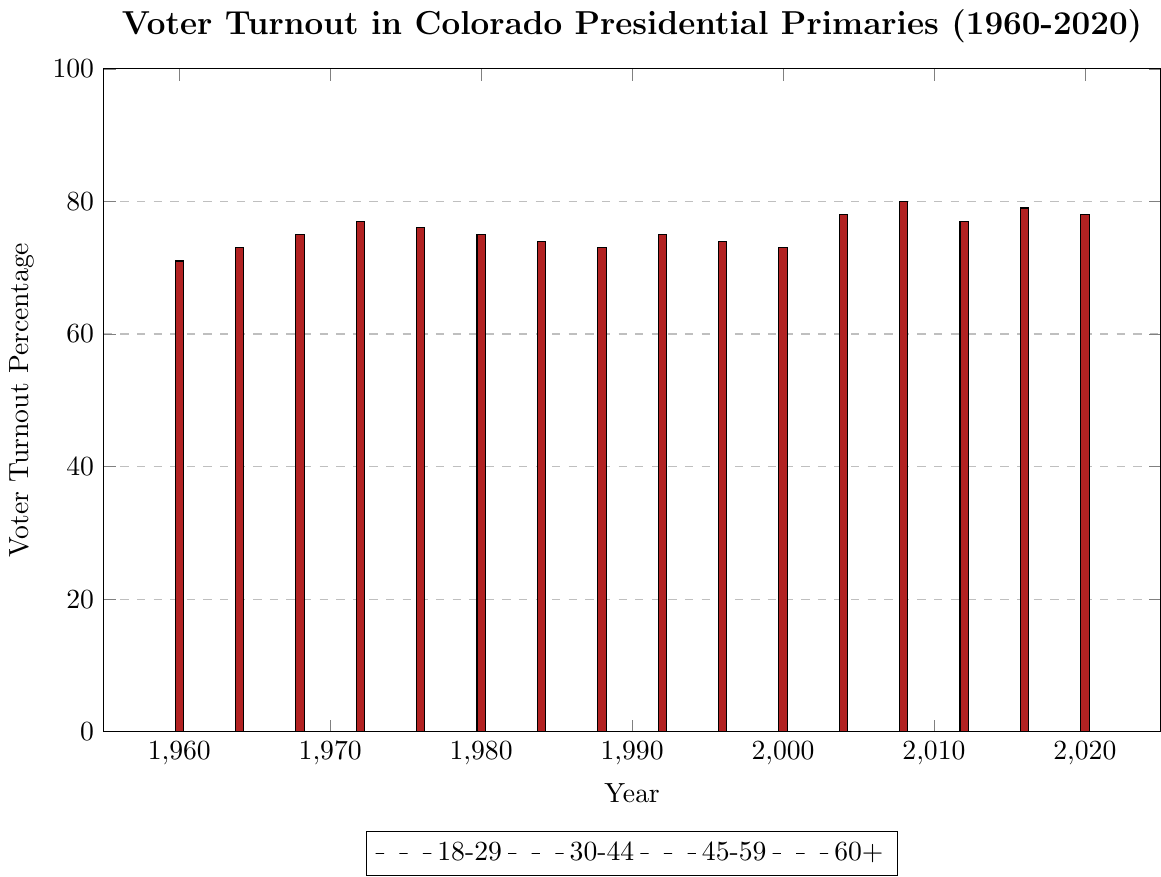Which age group had the highest voter turnout percentage in 2020? The "60+" age group had the highest voter turnout in 2020, with a percentage of 78. This can be seen by identifying the tallest bar in the 2020 section and noting its color corresponds to the "60+" group.
Answer: 60+ What was the overall trend for the 18-29 age group's voter turnout from 1960 to 2020? The trend for the 18-29 age group's voter turnout from 1960 to 2020 is generally fluctuating. Starting at 42% in 1960, dipping multiple times, and peaking at 52% in 2008 before slightly declining to 48% in 2020.
Answer: Fluctuating Compare the voter turnout percentages of the 30-44 and 45-59 age groups in the 2008 primary. Which group had a higher turnout and by how much? In the 2008 primary, the 30-44 age group had a voter turnout of 66%, while the 45-59 age group had a turnout of 75%. Subtracting 66% from 75%, the difference is 9%.
Answer: 45-59 age group by 9% Which age group saw the largest increase in voter turnout percentage from 1960 to 2008? Comparing the voter turnout percentages in 1960 and 2008 for each age group: 18-29 increased from 42% to 52%, 30-44 increased from 58% to 66%, 45-59 increased from 67% to 75%, and 60+ increased from 71% to 80%. The 60+ group had the largest increase of 9%.
Answer: 60+ What is the difference in voter turnout percentage between the highest and lowest age group in 1972? In 1972, the highest voter turnout was in the "60+" age group with 77%, and the lowest was in the "18-29" age group with 50%. The difference between them is 77% - 50% = 27%.
Answer: 27% Which age group had the most consistent (least fluctuating) voter turnout from 1960 to 2020? The 45-59 age group had the most consistent voter turnout, with percentages staying relatively close together ranging from 67% to 75%. This consistency is shown by the relatively stable height of the bars corresponding to this age group throughout the timeline.
Answer: 45-59 In which year did the 30-44 age group have the same voter turnout percentage as they did in 1964? The 30-44 age group had a voter turnout of 61% in 1964. Looking at the chart, they had the same percentage of 61% in the year 1964 only.
Answer: 1964 Calculate the average voter turnout percentage for the 18-29 group from 1960 to 2020. To find the average voter turnout for the 18-29 age group, sum the percentages (42+45+48+50+47+45+43+41+44+42+40+47+52+45+50+48) = 671, then divide by the number of years (16). The average is 671/16 = 41.9375%.
Answer: 41.94% Did the voter turnout percentage for the 45-59 age group ever fall below 65% between 1960 and 2020? By examining the chart, the voter turnout percentage for the 45-59 age group never fell below 65% at any point between 1960 and 2020. The lowest percentage was 67% in 1960 and 2000.
Answer: No 